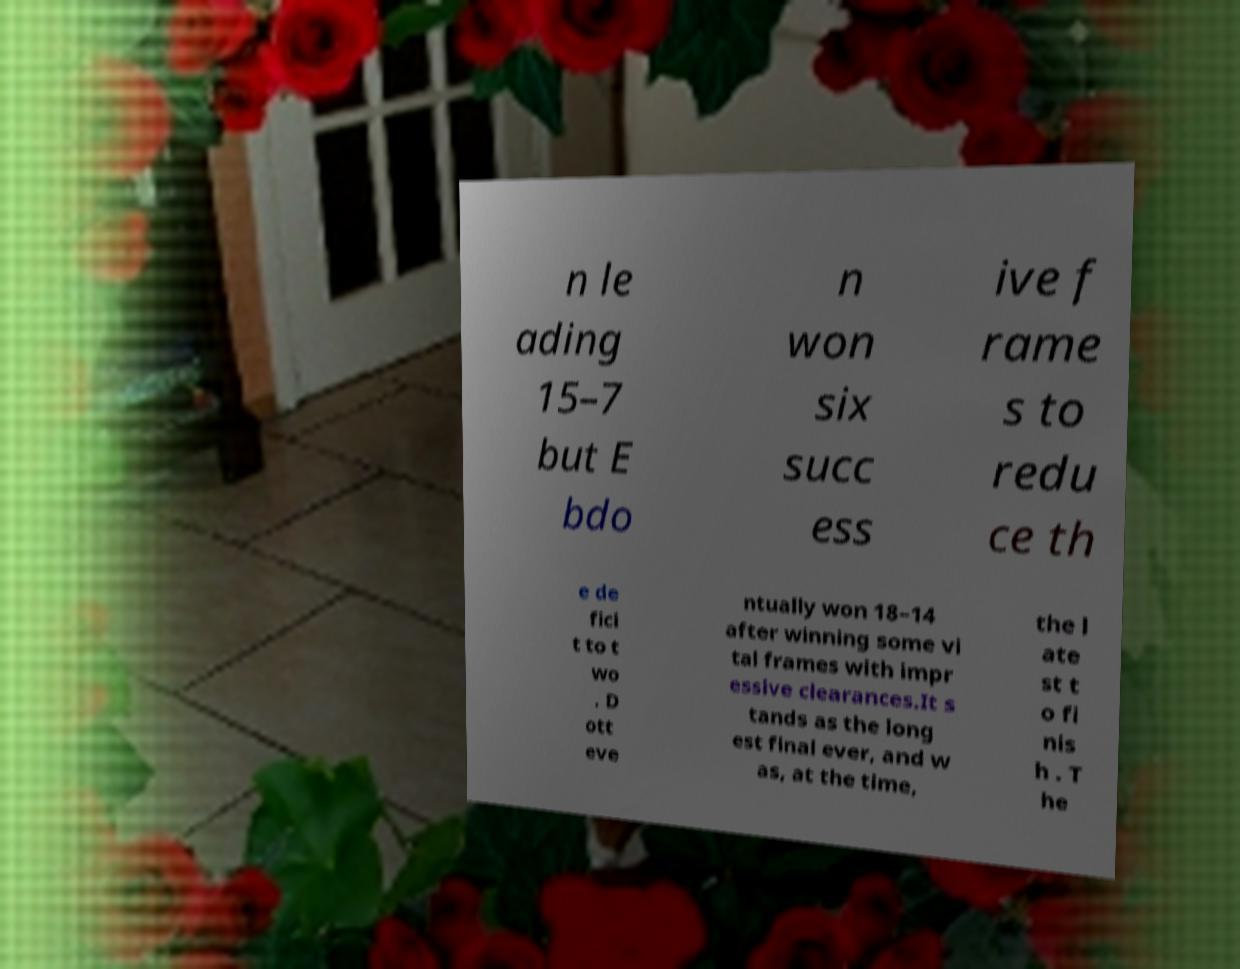Please identify and transcribe the text found in this image. n le ading 15–7 but E bdo n won six succ ess ive f rame s to redu ce th e de fici t to t wo . D ott eve ntually won 18–14 after winning some vi tal frames with impr essive clearances.It s tands as the long est final ever, and w as, at the time, the l ate st t o fi nis h . T he 